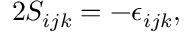Convert formula to latex. <formula><loc_0><loc_0><loc_500><loc_500>2 S _ { i j k } = - \epsilon _ { i j k } ,</formula> 